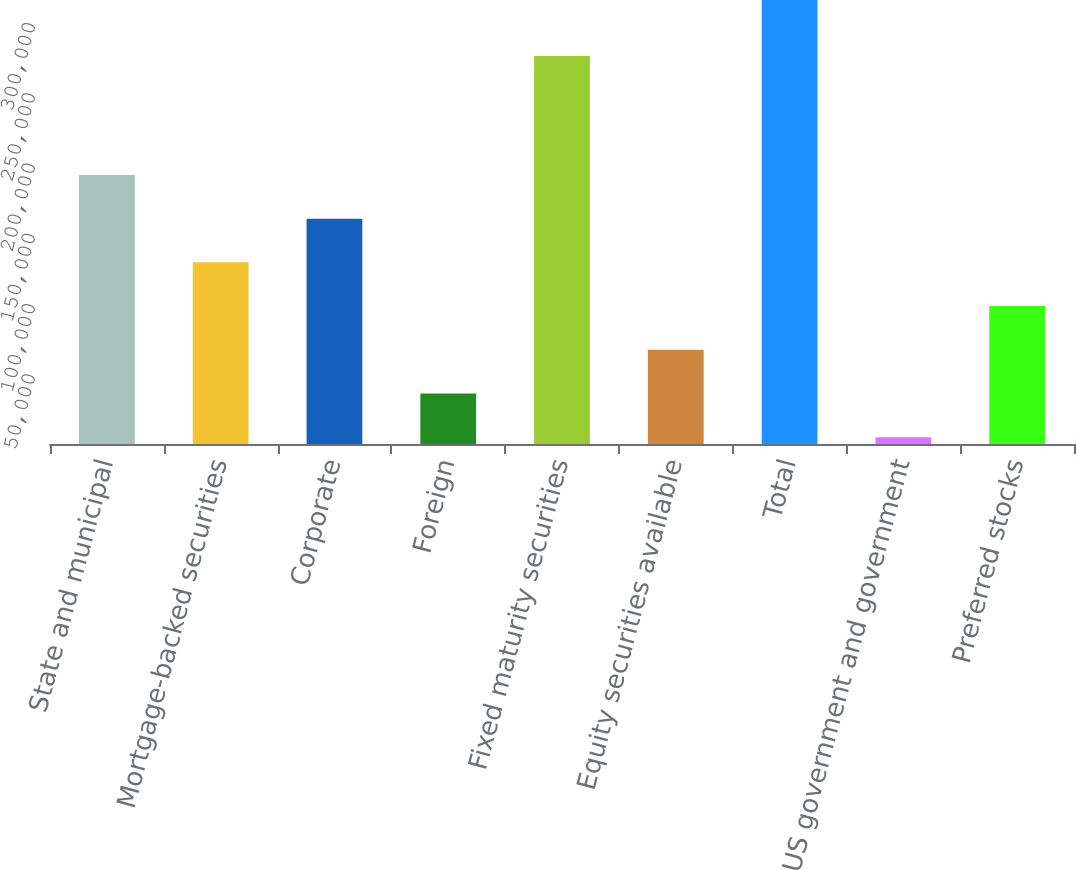Convert chart to OTSL. <chart><loc_0><loc_0><loc_500><loc_500><bar_chart><fcel>State and municipal<fcel>Mortgage-backed securities<fcel>Corporate<fcel>Foreign<fcel>Fixed maturity securities<fcel>Equity securities available<fcel>Total<fcel>US government and government<fcel>Preferred stocks<nl><fcel>191411<fcel>129207<fcel>160309<fcel>35901.8<fcel>276006<fcel>67003.6<fcel>315818<fcel>4800<fcel>98105.4<nl></chart> 